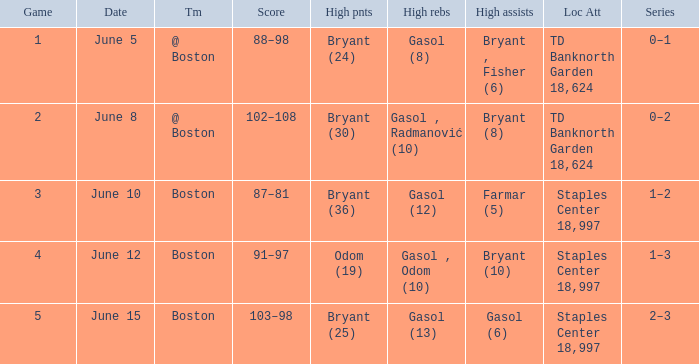Name the number of games on june 12 1.0. 